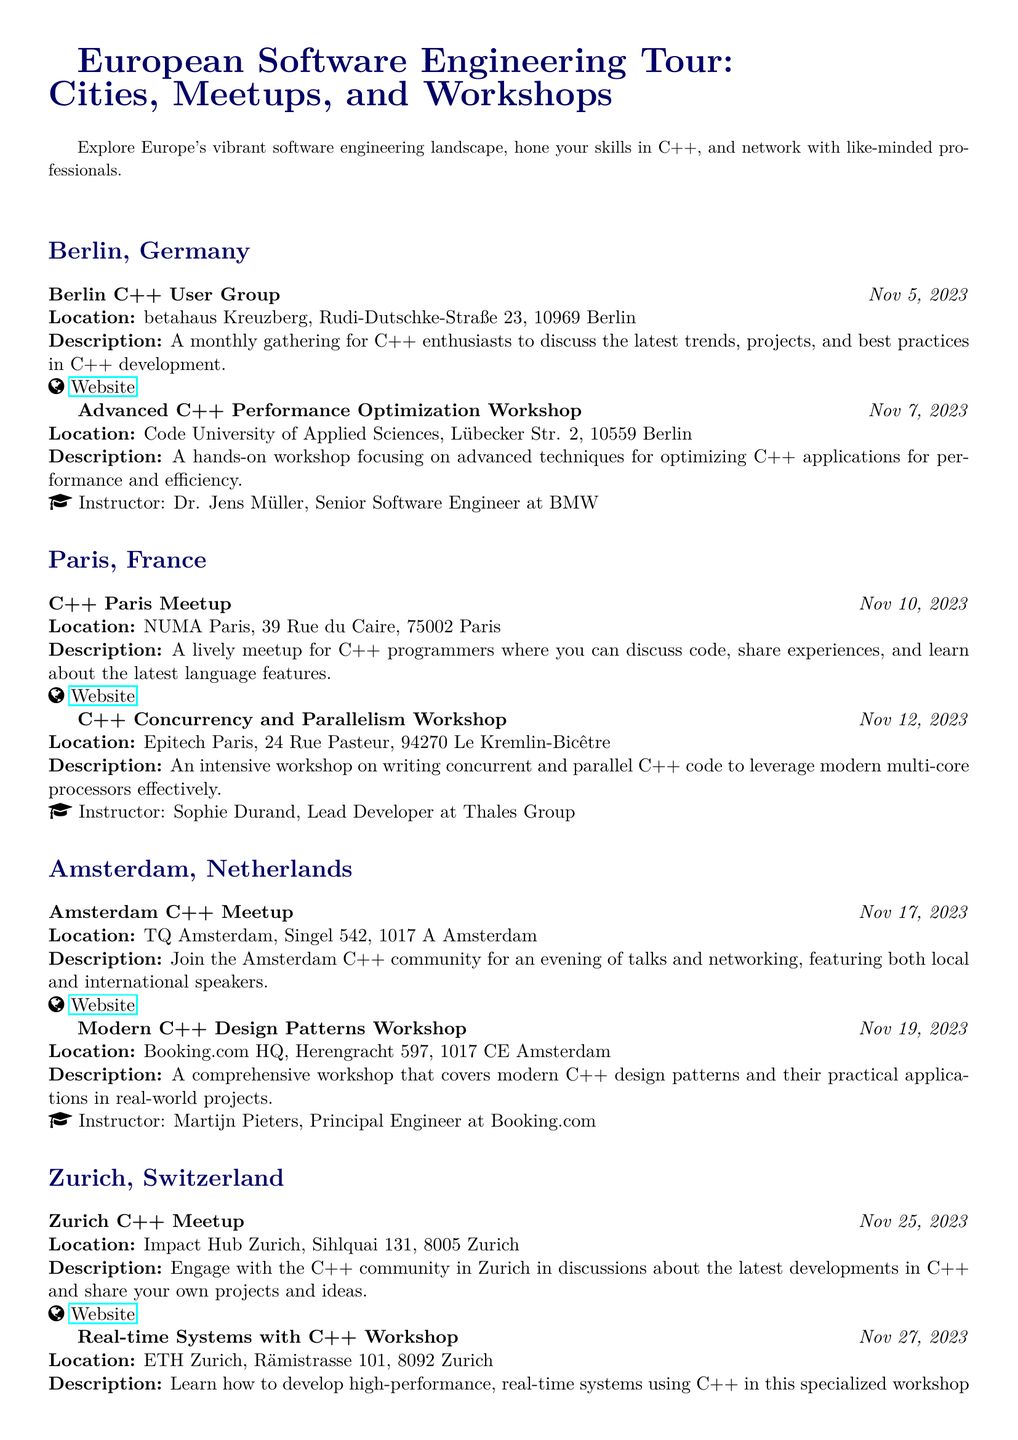What is the date of the Berlin C++ User Group meeting? The date is explicitly mentioned in the document as November 5, 2023.
Answer: November 5, 2023 Who is the instructor for the Advanced C++ Performance Optimization Workshop? The workshop's instructor is Dr. Jens Müller, as specified in the description of the activity.
Answer: Dr. Jens Müller What is the location of the C++ Concurrency and Parallelism Workshop? The document states that it will be held at Epitech Paris, located at 24 Rue Pasteur, 94270 Le Kremlin-Bicêtre.
Answer: Epitech Paris How many cities are included in the European Software Engineering Tour? The document lists four cities: Berlin, Paris, Amsterdam, and Zurich.
Answer: Four cities What type of workshop is being held in Zurich on November 27, 2023? The document indicates that the workshop focuses on developing real-time systems using C++, which is specified in the activity's description.
Answer: Real-time Systems with C++ Workshop What is the primary focus of the Amsterdam C++ Meetup? The description highlights that the meetup includes an evening of talks and networking, targeted at both local and international C++ speakers.
Answer: Talks and networking What day is the C++ Paris Meetup scheduled for? The document states that it is scheduled for November 10, 2023.
Answer: November 10, 2023 Who is the lead developer for the C++ Concurrency and Parallelism Workshop? The lead developer is identified as Sophie Durand, mentioned in the workshop's instructor section.
Answer: Sophie Durand What venue hosts the Modern C++ Design Patterns Workshop? It is held at Booking.com HQ, as specified in the location part of the activity description.
Answer: Booking.com HQ 